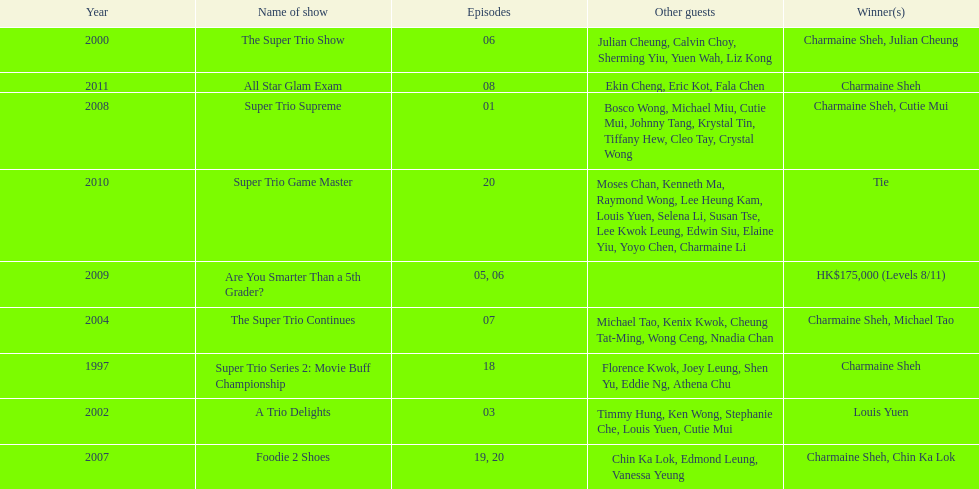In variety shows, how often has charmaine sheh been victorious? 6. 